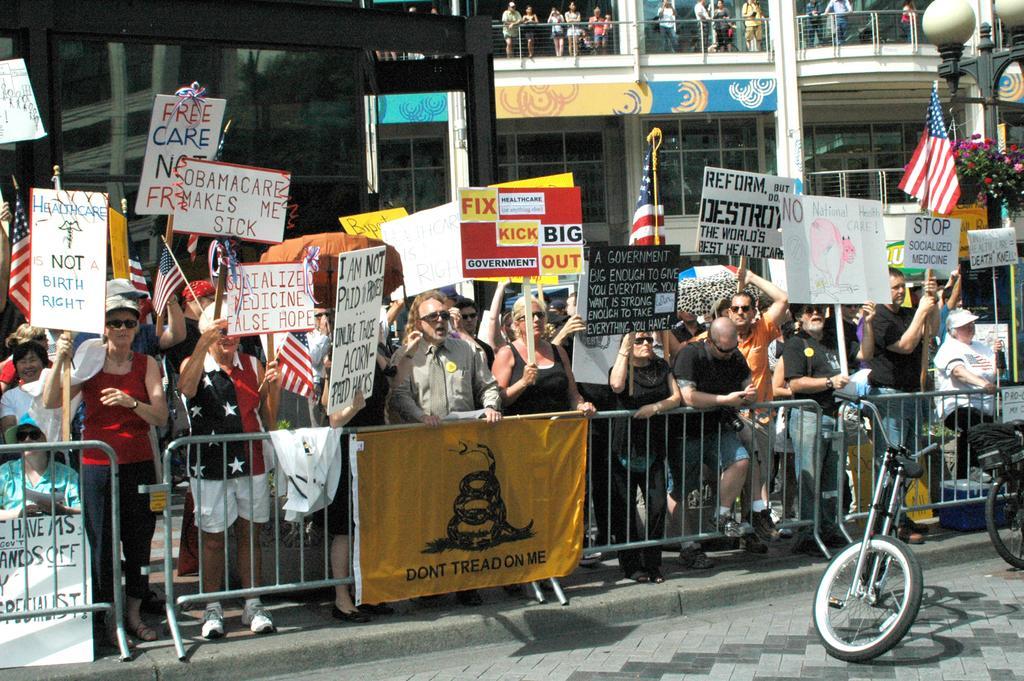Can you describe this image briefly? In the image in the center, we can see a few people are standing and they are holding banners. And we can see the fences and cycles. In the background, we can see buildings, trees, flags, poles, flags, pillars, fences, banners, sign boards and few people are standing. 